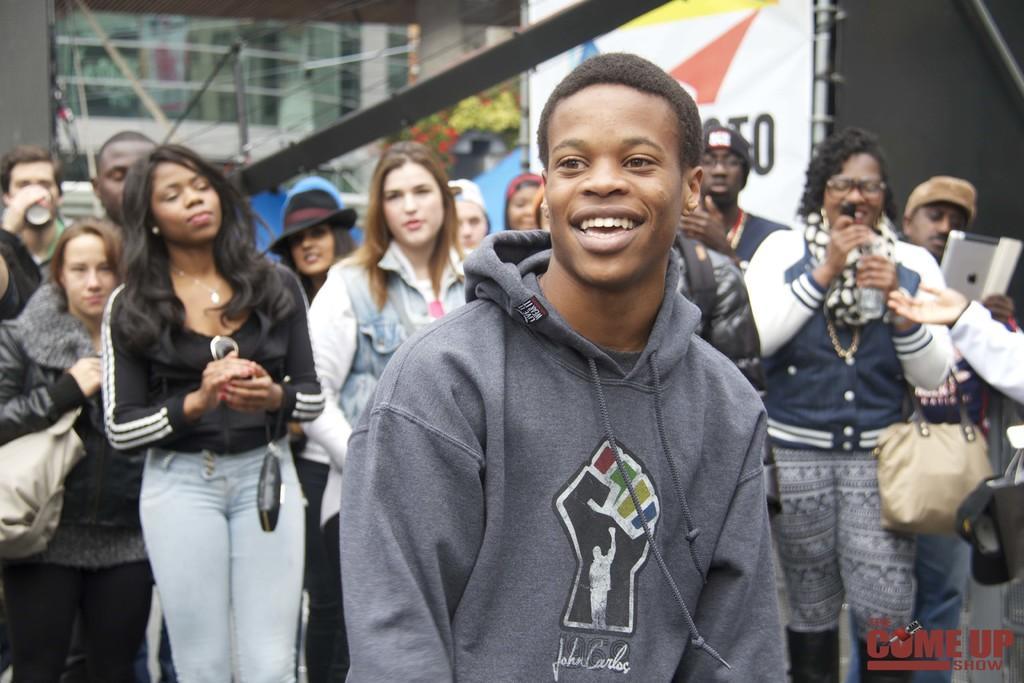Describe this image in one or two sentences. In this image there is a person standing and smiling, and in the background there are group of persons standing and holding some objects , building, banner and a watermark on the image. 